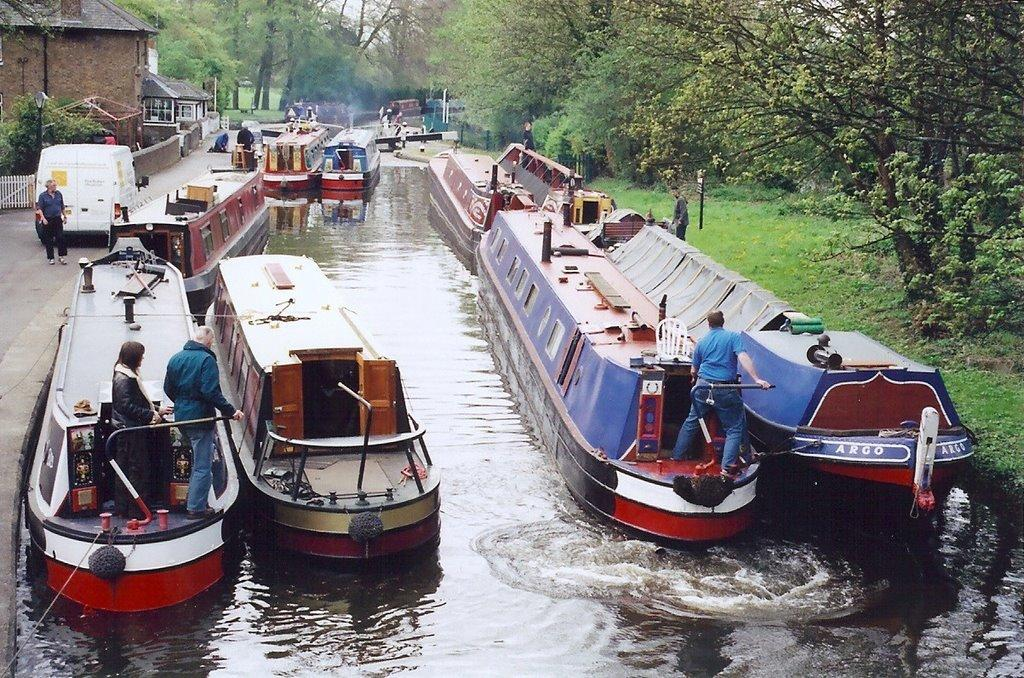<image>
Give a short and clear explanation of the subsequent image. A group of boats are lined up in a small river and one of them has the name Argo on the side. 